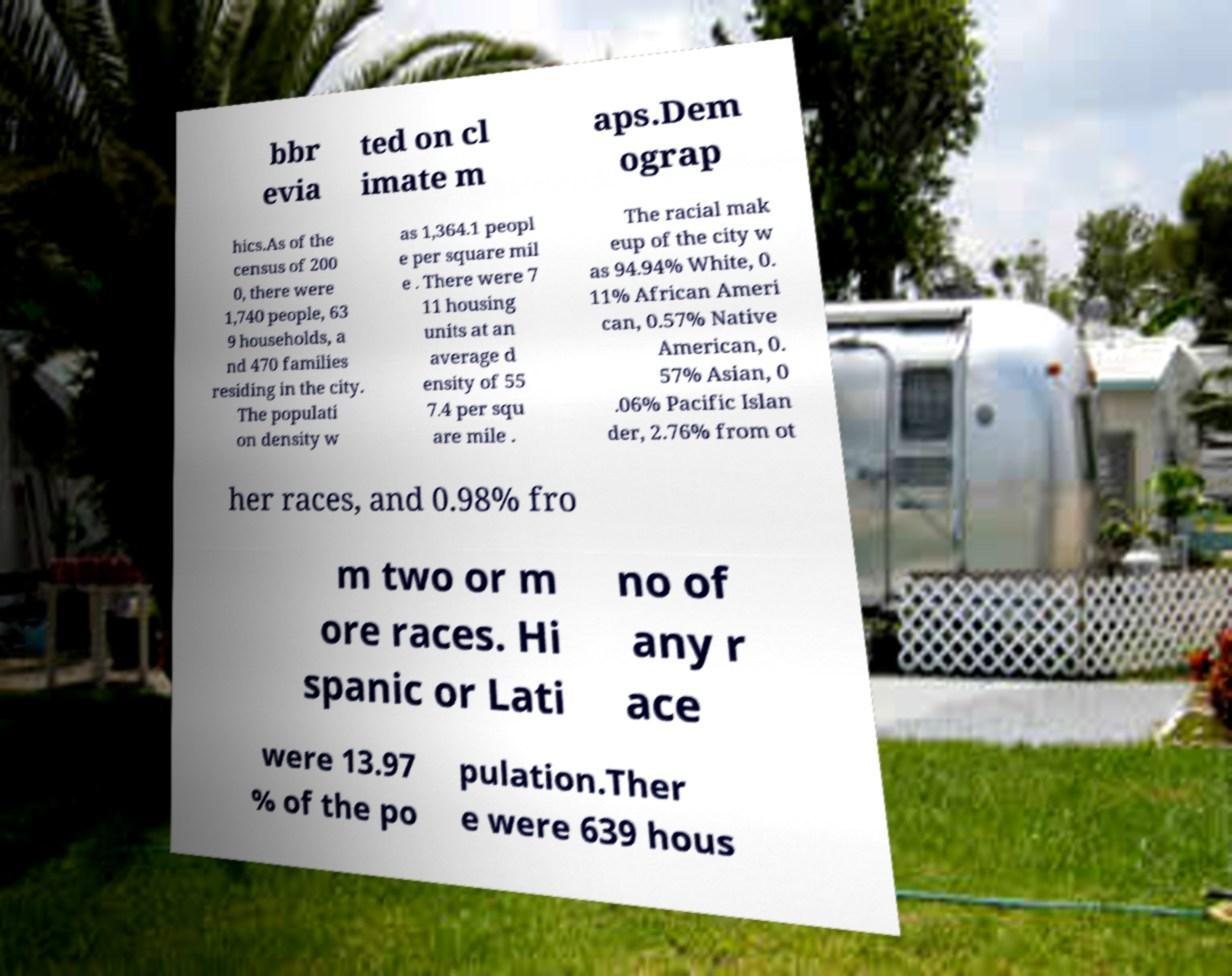There's text embedded in this image that I need extracted. Can you transcribe it verbatim? bbr evia ted on cl imate m aps.Dem ograp hics.As of the census of 200 0, there were 1,740 people, 63 9 households, a nd 470 families residing in the city. The populati on density w as 1,364.1 peopl e per square mil e . There were 7 11 housing units at an average d ensity of 55 7.4 per squ are mile . The racial mak eup of the city w as 94.94% White, 0. 11% African Ameri can, 0.57% Native American, 0. 57% Asian, 0 .06% Pacific Islan der, 2.76% from ot her races, and 0.98% fro m two or m ore races. Hi spanic or Lati no of any r ace were 13.97 % of the po pulation.Ther e were 639 hous 